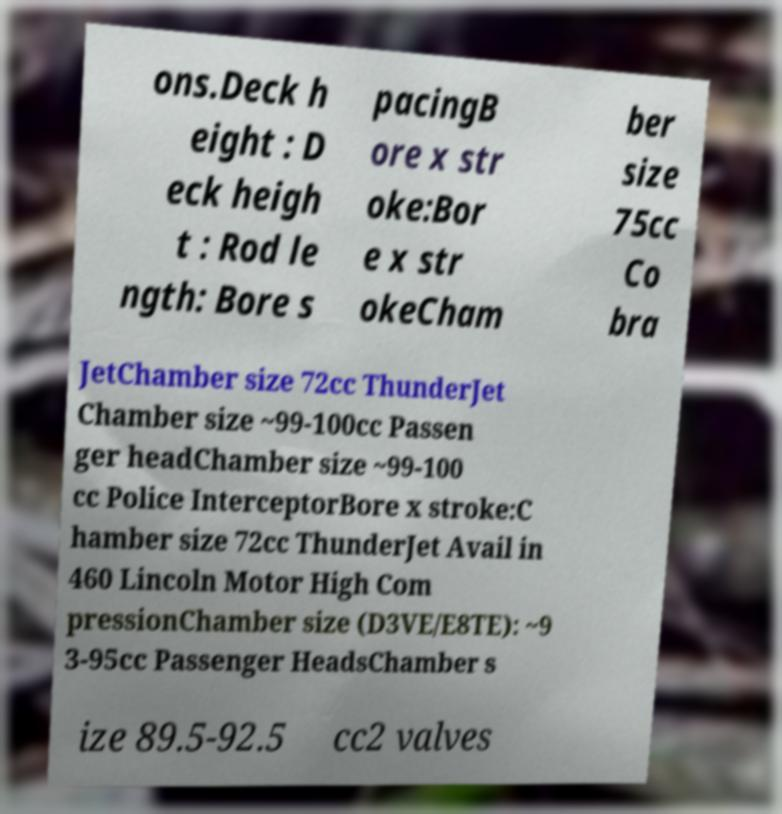Could you assist in decoding the text presented in this image and type it out clearly? ons.Deck h eight : D eck heigh t : Rod le ngth: Bore s pacingB ore x str oke:Bor e x str okeCham ber size 75cc Co bra JetChamber size 72cc ThunderJet Chamber size ~99-100cc Passen ger headChamber size ~99-100 cc Police InterceptorBore x stroke:C hamber size 72cc ThunderJet Avail in 460 Lincoln Motor High Com pressionChamber size (D3VE/E8TE): ~9 3-95cc Passenger HeadsChamber s ize 89.5-92.5 cc2 valves 